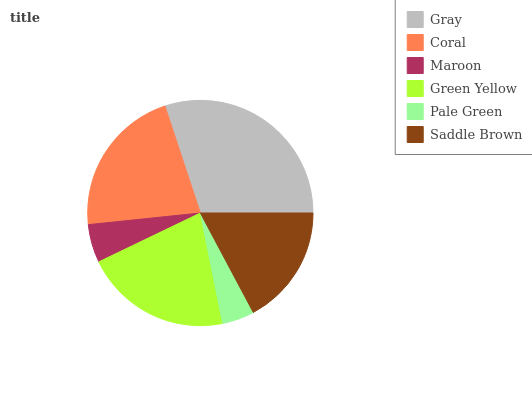Is Pale Green the minimum?
Answer yes or no. Yes. Is Gray the maximum?
Answer yes or no. Yes. Is Coral the minimum?
Answer yes or no. No. Is Coral the maximum?
Answer yes or no. No. Is Gray greater than Coral?
Answer yes or no. Yes. Is Coral less than Gray?
Answer yes or no. Yes. Is Coral greater than Gray?
Answer yes or no. No. Is Gray less than Coral?
Answer yes or no. No. Is Green Yellow the high median?
Answer yes or no. Yes. Is Saddle Brown the low median?
Answer yes or no. Yes. Is Gray the high median?
Answer yes or no. No. Is Coral the low median?
Answer yes or no. No. 